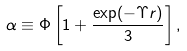<formula> <loc_0><loc_0><loc_500><loc_500>\alpha \equiv \Phi \left [ 1 + \frac { \exp ( - \Upsilon r ) } { 3 } \right ] ,</formula> 